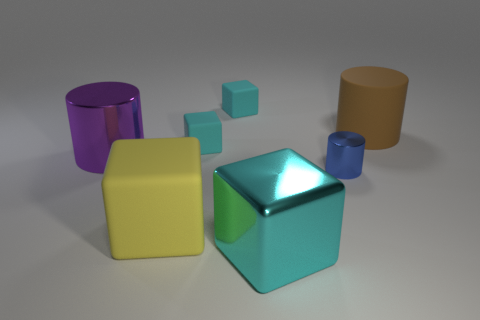Add 1 rubber things. How many objects exist? 8 Subtract all big cylinders. How many cylinders are left? 1 Subtract all blue balls. How many cyan blocks are left? 3 Subtract all yellow cubes. How many cubes are left? 3 Subtract all blocks. How many objects are left? 3 Subtract 0 purple spheres. How many objects are left? 7 Subtract all purple cylinders. Subtract all gray cubes. How many cylinders are left? 2 Subtract all large yellow rubber cubes. Subtract all small yellow shiny things. How many objects are left? 6 Add 1 cyan cubes. How many cyan cubes are left? 4 Add 1 large yellow blocks. How many large yellow blocks exist? 2 